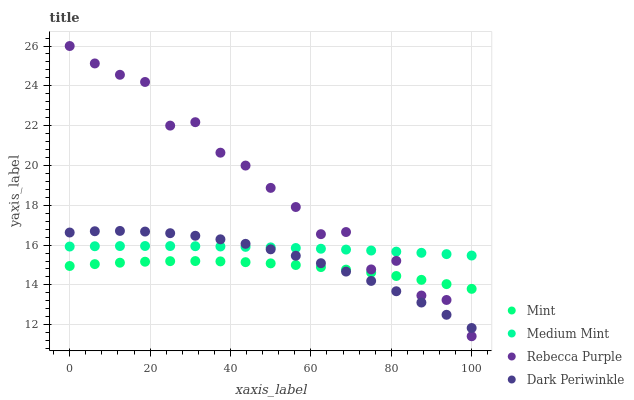Does Mint have the minimum area under the curve?
Answer yes or no. Yes. Does Rebecca Purple have the maximum area under the curve?
Answer yes or no. Yes. Does Rebecca Purple have the minimum area under the curve?
Answer yes or no. No. Does Mint have the maximum area under the curve?
Answer yes or no. No. Is Medium Mint the smoothest?
Answer yes or no. Yes. Is Rebecca Purple the roughest?
Answer yes or no. Yes. Is Mint the smoothest?
Answer yes or no. No. Is Mint the roughest?
Answer yes or no. No. Does Rebecca Purple have the lowest value?
Answer yes or no. Yes. Does Mint have the lowest value?
Answer yes or no. No. Does Rebecca Purple have the highest value?
Answer yes or no. Yes. Does Mint have the highest value?
Answer yes or no. No. Is Mint less than Medium Mint?
Answer yes or no. Yes. Is Medium Mint greater than Mint?
Answer yes or no. Yes. Does Mint intersect Dark Periwinkle?
Answer yes or no. Yes. Is Mint less than Dark Periwinkle?
Answer yes or no. No. Is Mint greater than Dark Periwinkle?
Answer yes or no. No. Does Mint intersect Medium Mint?
Answer yes or no. No. 